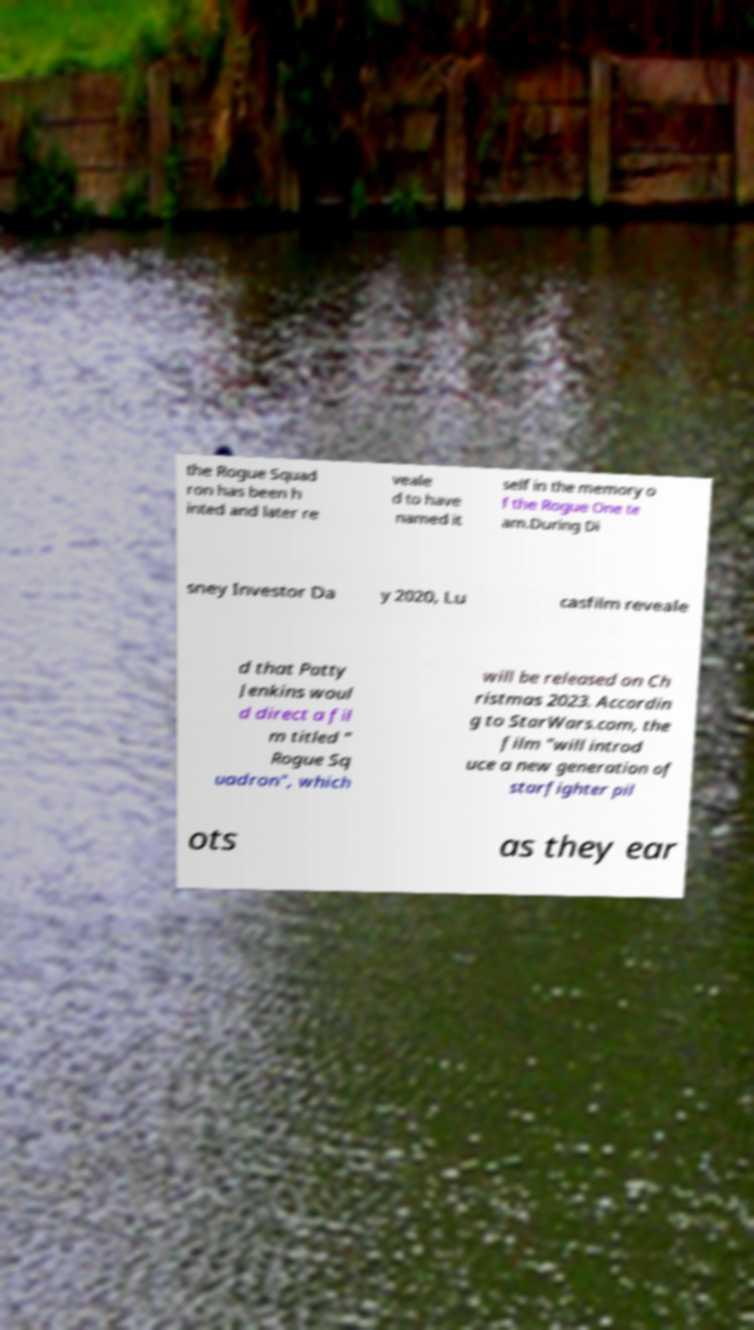Could you extract and type out the text from this image? the Rogue Squad ron has been h inted and later re veale d to have named it self in the memory o f the Rogue One te am.During Di sney Investor Da y 2020, Lu casfilm reveale d that Patty Jenkins woul d direct a fil m titled " Rogue Sq uadron", which will be released on Ch ristmas 2023. Accordin g to StarWars.com, the film "will introd uce a new generation of starfighter pil ots as they ear 